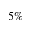Convert formula to latex. <formula><loc_0><loc_0><loc_500><loc_500>5 \%</formula> 